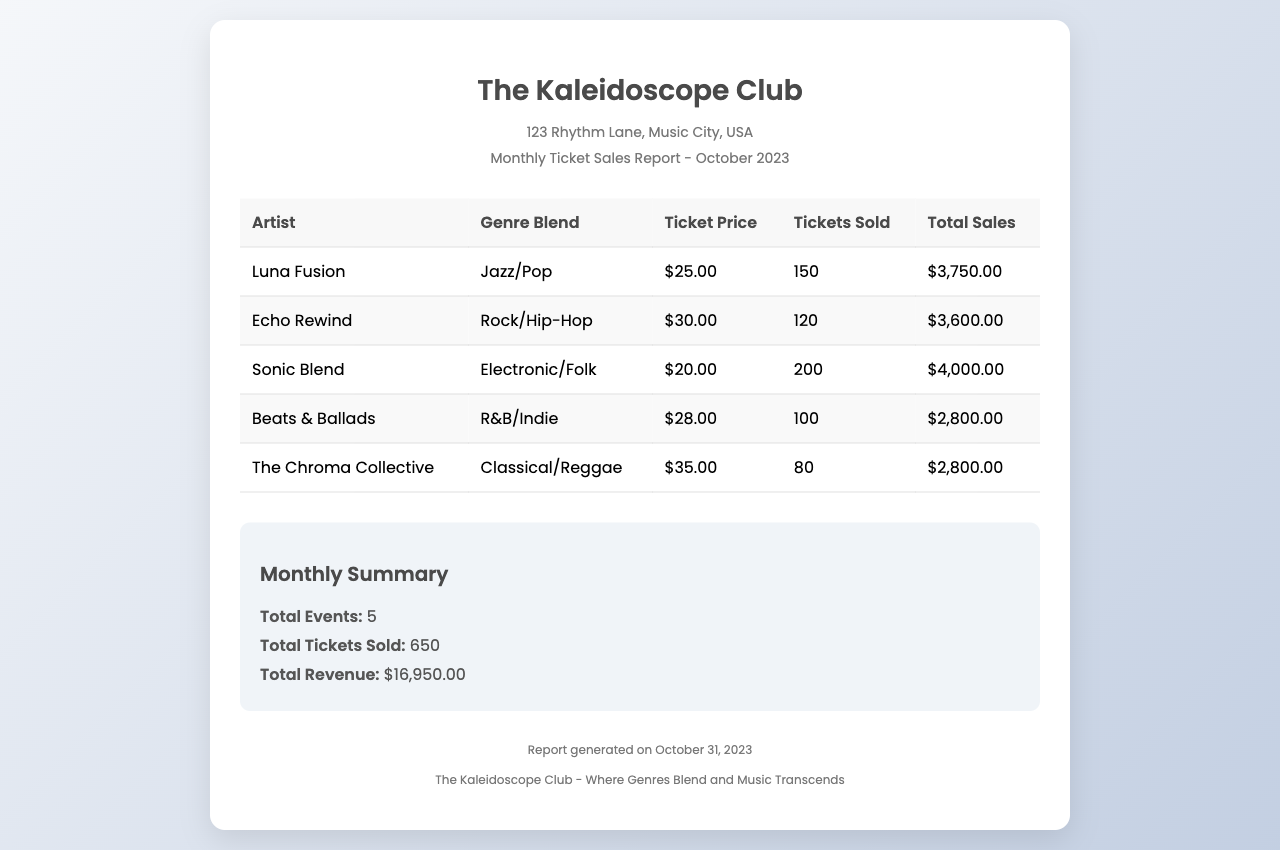What is the name of the venue? The venue is referred to as The Kaleidoscope Club in the header section of the document.
Answer: The Kaleidoscope Club What is the date of the report? The report is dated October 31, 2023, as mentioned in the footer.
Answer: October 31, 2023 How many tickets were sold for Sonic Blend? The number of tickets sold for Sonic Blend is listed as 200 in the table.
Answer: 200 What genre blend does Echo Rewind represent? Echo Rewind's genre blend is specified as Rock/Hip-Hop in the document.
Answer: Rock/Hip-Hop What is the total revenue reported for October 2023? The total revenue is presented in the summary section, which states it is $16,950.00.
Answer: $16,950.00 Which artist had the highest ticket price? The artist with the highest ticket price is The Chroma Collective, priced at $35.00.
Answer: The Chroma Collective How many total events were held in October 2023? The total events listed in the summary section total 5.
Answer: 5 What is the ticket price for Luna Fusion? The ticket price for Luna Fusion is clearly given as $25.00 in the table.
Answer: $25.00 What is the average number of tickets sold per event? The average is calculated by dividing total tickets sold (650) by total events (5), which equals 130.
Answer: 130 